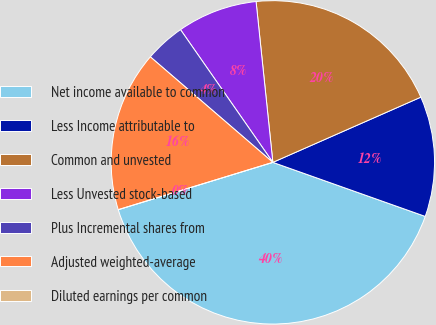Convert chart to OTSL. <chart><loc_0><loc_0><loc_500><loc_500><pie_chart><fcel>Net income available to common<fcel>Less Income attributable to<fcel>Common and unvested<fcel>Less Unvested stock-based<fcel>Plus Incremental shares from<fcel>Adjusted weighted-average<fcel>Diluted earnings per common<nl><fcel>39.85%<fcel>12.03%<fcel>20.05%<fcel>8.02%<fcel>4.01%<fcel>16.04%<fcel>0.0%<nl></chart> 